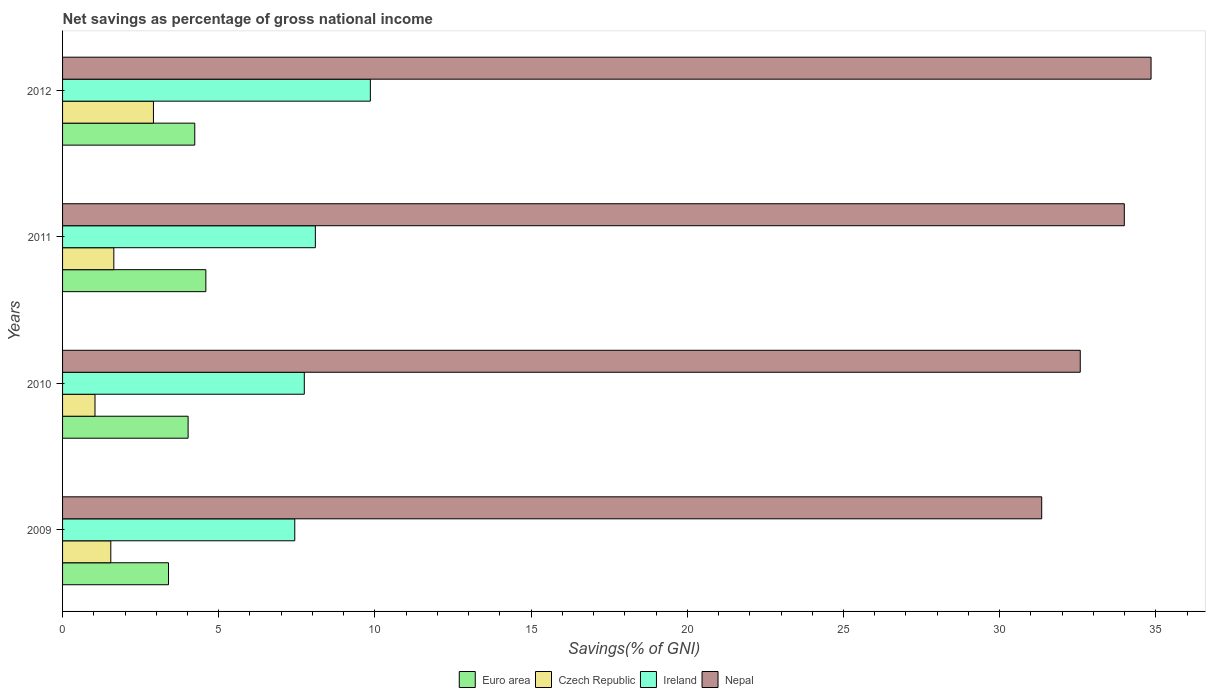How many groups of bars are there?
Your response must be concise. 4. Are the number of bars per tick equal to the number of legend labels?
Offer a terse response. Yes. Are the number of bars on each tick of the Y-axis equal?
Offer a very short reply. Yes. How many bars are there on the 1st tick from the bottom?
Make the answer very short. 4. What is the label of the 3rd group of bars from the top?
Ensure brevity in your answer.  2010. What is the total savings in Czech Republic in 2010?
Your answer should be very brief. 1.04. Across all years, what is the maximum total savings in Euro area?
Your answer should be very brief. 4.59. Across all years, what is the minimum total savings in Euro area?
Offer a very short reply. 3.39. In which year was the total savings in Ireland maximum?
Your answer should be compact. 2012. In which year was the total savings in Euro area minimum?
Your answer should be compact. 2009. What is the total total savings in Ireland in the graph?
Provide a succinct answer. 33.12. What is the difference between the total savings in Ireland in 2010 and that in 2011?
Provide a succinct answer. -0.35. What is the difference between the total savings in Nepal in 2010 and the total savings in Czech Republic in 2012?
Ensure brevity in your answer.  29.67. What is the average total savings in Czech Republic per year?
Offer a very short reply. 1.78. In the year 2010, what is the difference between the total savings in Euro area and total savings in Czech Republic?
Your answer should be compact. 2.98. In how many years, is the total savings in Nepal greater than 32 %?
Your answer should be very brief. 3. What is the ratio of the total savings in Ireland in 2010 to that in 2011?
Your answer should be compact. 0.96. Is the total savings in Czech Republic in 2010 less than that in 2012?
Provide a short and direct response. Yes. Is the difference between the total savings in Euro area in 2009 and 2011 greater than the difference between the total savings in Czech Republic in 2009 and 2011?
Keep it short and to the point. No. What is the difference between the highest and the second highest total savings in Ireland?
Your response must be concise. 1.76. What is the difference between the highest and the lowest total savings in Ireland?
Your answer should be compact. 2.42. Is the sum of the total savings in Nepal in 2010 and 2012 greater than the maximum total savings in Czech Republic across all years?
Keep it short and to the point. Yes. What does the 1st bar from the top in 2009 represents?
Offer a terse response. Nepal. What does the 4th bar from the bottom in 2012 represents?
Offer a terse response. Nepal. Is it the case that in every year, the sum of the total savings in Czech Republic and total savings in Ireland is greater than the total savings in Euro area?
Ensure brevity in your answer.  Yes. How many bars are there?
Your answer should be compact. 16. How many years are there in the graph?
Your answer should be very brief. 4. What is the difference between two consecutive major ticks on the X-axis?
Your response must be concise. 5. Are the values on the major ticks of X-axis written in scientific E-notation?
Your answer should be compact. No. Does the graph contain any zero values?
Your answer should be very brief. No. How many legend labels are there?
Keep it short and to the point. 4. How are the legend labels stacked?
Provide a short and direct response. Horizontal. What is the title of the graph?
Keep it short and to the point. Net savings as percentage of gross national income. Does "Malawi" appear as one of the legend labels in the graph?
Ensure brevity in your answer.  No. What is the label or title of the X-axis?
Your answer should be compact. Savings(% of GNI). What is the label or title of the Y-axis?
Your answer should be compact. Years. What is the Savings(% of GNI) of Euro area in 2009?
Provide a succinct answer. 3.39. What is the Savings(% of GNI) of Czech Republic in 2009?
Provide a succinct answer. 1.54. What is the Savings(% of GNI) of Ireland in 2009?
Keep it short and to the point. 7.43. What is the Savings(% of GNI) of Nepal in 2009?
Give a very brief answer. 31.35. What is the Savings(% of GNI) in Euro area in 2010?
Make the answer very short. 4.02. What is the Savings(% of GNI) of Czech Republic in 2010?
Your answer should be very brief. 1.04. What is the Savings(% of GNI) in Ireland in 2010?
Provide a short and direct response. 7.74. What is the Savings(% of GNI) in Nepal in 2010?
Provide a succinct answer. 32.58. What is the Savings(% of GNI) in Euro area in 2011?
Keep it short and to the point. 4.59. What is the Savings(% of GNI) of Czech Republic in 2011?
Give a very brief answer. 1.64. What is the Savings(% of GNI) of Ireland in 2011?
Your response must be concise. 8.09. What is the Savings(% of GNI) of Nepal in 2011?
Offer a terse response. 33.99. What is the Savings(% of GNI) of Euro area in 2012?
Provide a short and direct response. 4.23. What is the Savings(% of GNI) of Czech Republic in 2012?
Your answer should be compact. 2.91. What is the Savings(% of GNI) of Ireland in 2012?
Provide a succinct answer. 9.85. What is the Savings(% of GNI) of Nepal in 2012?
Your answer should be compact. 34.85. Across all years, what is the maximum Savings(% of GNI) of Euro area?
Offer a terse response. 4.59. Across all years, what is the maximum Savings(% of GNI) in Czech Republic?
Give a very brief answer. 2.91. Across all years, what is the maximum Savings(% of GNI) in Ireland?
Your answer should be very brief. 9.85. Across all years, what is the maximum Savings(% of GNI) of Nepal?
Your answer should be compact. 34.85. Across all years, what is the minimum Savings(% of GNI) in Euro area?
Give a very brief answer. 3.39. Across all years, what is the minimum Savings(% of GNI) of Czech Republic?
Your response must be concise. 1.04. Across all years, what is the minimum Savings(% of GNI) of Ireland?
Give a very brief answer. 7.43. Across all years, what is the minimum Savings(% of GNI) in Nepal?
Offer a very short reply. 31.35. What is the total Savings(% of GNI) in Euro area in the graph?
Your answer should be compact. 16.23. What is the total Savings(% of GNI) of Czech Republic in the graph?
Your response must be concise. 7.13. What is the total Savings(% of GNI) of Ireland in the graph?
Keep it short and to the point. 33.12. What is the total Savings(% of GNI) of Nepal in the graph?
Ensure brevity in your answer.  132.77. What is the difference between the Savings(% of GNI) in Euro area in 2009 and that in 2010?
Provide a short and direct response. -0.63. What is the difference between the Savings(% of GNI) of Czech Republic in 2009 and that in 2010?
Provide a succinct answer. 0.51. What is the difference between the Savings(% of GNI) of Ireland in 2009 and that in 2010?
Make the answer very short. -0.31. What is the difference between the Savings(% of GNI) of Nepal in 2009 and that in 2010?
Keep it short and to the point. -1.23. What is the difference between the Savings(% of GNI) of Euro area in 2009 and that in 2011?
Ensure brevity in your answer.  -1.2. What is the difference between the Savings(% of GNI) in Czech Republic in 2009 and that in 2011?
Provide a succinct answer. -0.1. What is the difference between the Savings(% of GNI) in Ireland in 2009 and that in 2011?
Your answer should be very brief. -0.66. What is the difference between the Savings(% of GNI) in Nepal in 2009 and that in 2011?
Offer a very short reply. -2.64. What is the difference between the Savings(% of GNI) of Euro area in 2009 and that in 2012?
Give a very brief answer. -0.84. What is the difference between the Savings(% of GNI) in Czech Republic in 2009 and that in 2012?
Provide a succinct answer. -1.37. What is the difference between the Savings(% of GNI) of Ireland in 2009 and that in 2012?
Provide a short and direct response. -2.42. What is the difference between the Savings(% of GNI) in Nepal in 2009 and that in 2012?
Give a very brief answer. -3.5. What is the difference between the Savings(% of GNI) of Euro area in 2010 and that in 2011?
Your answer should be compact. -0.57. What is the difference between the Savings(% of GNI) in Czech Republic in 2010 and that in 2011?
Give a very brief answer. -0.6. What is the difference between the Savings(% of GNI) in Ireland in 2010 and that in 2011?
Your answer should be compact. -0.35. What is the difference between the Savings(% of GNI) of Nepal in 2010 and that in 2011?
Offer a very short reply. -1.41. What is the difference between the Savings(% of GNI) in Euro area in 2010 and that in 2012?
Provide a short and direct response. -0.21. What is the difference between the Savings(% of GNI) of Czech Republic in 2010 and that in 2012?
Your response must be concise. -1.87. What is the difference between the Savings(% of GNI) of Ireland in 2010 and that in 2012?
Your response must be concise. -2.12. What is the difference between the Savings(% of GNI) in Nepal in 2010 and that in 2012?
Your answer should be compact. -2.27. What is the difference between the Savings(% of GNI) of Euro area in 2011 and that in 2012?
Offer a terse response. 0.35. What is the difference between the Savings(% of GNI) in Czech Republic in 2011 and that in 2012?
Offer a terse response. -1.27. What is the difference between the Savings(% of GNI) of Ireland in 2011 and that in 2012?
Make the answer very short. -1.76. What is the difference between the Savings(% of GNI) in Nepal in 2011 and that in 2012?
Provide a succinct answer. -0.86. What is the difference between the Savings(% of GNI) of Euro area in 2009 and the Savings(% of GNI) of Czech Republic in 2010?
Keep it short and to the point. 2.35. What is the difference between the Savings(% of GNI) of Euro area in 2009 and the Savings(% of GNI) of Ireland in 2010?
Ensure brevity in your answer.  -4.35. What is the difference between the Savings(% of GNI) of Euro area in 2009 and the Savings(% of GNI) of Nepal in 2010?
Provide a short and direct response. -29.19. What is the difference between the Savings(% of GNI) of Czech Republic in 2009 and the Savings(% of GNI) of Ireland in 2010?
Your answer should be very brief. -6.19. What is the difference between the Savings(% of GNI) of Czech Republic in 2009 and the Savings(% of GNI) of Nepal in 2010?
Provide a short and direct response. -31.04. What is the difference between the Savings(% of GNI) of Ireland in 2009 and the Savings(% of GNI) of Nepal in 2010?
Provide a short and direct response. -25.15. What is the difference between the Savings(% of GNI) of Euro area in 2009 and the Savings(% of GNI) of Czech Republic in 2011?
Make the answer very short. 1.75. What is the difference between the Savings(% of GNI) in Euro area in 2009 and the Savings(% of GNI) in Ireland in 2011?
Offer a very short reply. -4.7. What is the difference between the Savings(% of GNI) of Euro area in 2009 and the Savings(% of GNI) of Nepal in 2011?
Give a very brief answer. -30.6. What is the difference between the Savings(% of GNI) of Czech Republic in 2009 and the Savings(% of GNI) of Ireland in 2011?
Give a very brief answer. -6.55. What is the difference between the Savings(% of GNI) in Czech Republic in 2009 and the Savings(% of GNI) in Nepal in 2011?
Provide a short and direct response. -32.45. What is the difference between the Savings(% of GNI) in Ireland in 2009 and the Savings(% of GNI) in Nepal in 2011?
Make the answer very short. -26.56. What is the difference between the Savings(% of GNI) of Euro area in 2009 and the Savings(% of GNI) of Czech Republic in 2012?
Offer a very short reply. 0.48. What is the difference between the Savings(% of GNI) in Euro area in 2009 and the Savings(% of GNI) in Ireland in 2012?
Offer a terse response. -6.46. What is the difference between the Savings(% of GNI) in Euro area in 2009 and the Savings(% of GNI) in Nepal in 2012?
Give a very brief answer. -31.46. What is the difference between the Savings(% of GNI) of Czech Republic in 2009 and the Savings(% of GNI) of Ireland in 2012?
Keep it short and to the point. -8.31. What is the difference between the Savings(% of GNI) in Czech Republic in 2009 and the Savings(% of GNI) in Nepal in 2012?
Keep it short and to the point. -33.3. What is the difference between the Savings(% of GNI) of Ireland in 2009 and the Savings(% of GNI) of Nepal in 2012?
Provide a short and direct response. -27.41. What is the difference between the Savings(% of GNI) of Euro area in 2010 and the Savings(% of GNI) of Czech Republic in 2011?
Your response must be concise. 2.38. What is the difference between the Savings(% of GNI) in Euro area in 2010 and the Savings(% of GNI) in Ireland in 2011?
Offer a very short reply. -4.07. What is the difference between the Savings(% of GNI) of Euro area in 2010 and the Savings(% of GNI) of Nepal in 2011?
Provide a short and direct response. -29.97. What is the difference between the Savings(% of GNI) of Czech Republic in 2010 and the Savings(% of GNI) of Ireland in 2011?
Offer a very short reply. -7.05. What is the difference between the Savings(% of GNI) in Czech Republic in 2010 and the Savings(% of GNI) in Nepal in 2011?
Give a very brief answer. -32.95. What is the difference between the Savings(% of GNI) of Ireland in 2010 and the Savings(% of GNI) of Nepal in 2011?
Your answer should be very brief. -26.25. What is the difference between the Savings(% of GNI) of Euro area in 2010 and the Savings(% of GNI) of Czech Republic in 2012?
Your answer should be compact. 1.11. What is the difference between the Savings(% of GNI) in Euro area in 2010 and the Savings(% of GNI) in Ireland in 2012?
Make the answer very short. -5.83. What is the difference between the Savings(% of GNI) of Euro area in 2010 and the Savings(% of GNI) of Nepal in 2012?
Your answer should be very brief. -30.83. What is the difference between the Savings(% of GNI) of Czech Republic in 2010 and the Savings(% of GNI) of Ireland in 2012?
Provide a succinct answer. -8.82. What is the difference between the Savings(% of GNI) in Czech Republic in 2010 and the Savings(% of GNI) in Nepal in 2012?
Your answer should be very brief. -33.81. What is the difference between the Savings(% of GNI) of Ireland in 2010 and the Savings(% of GNI) of Nepal in 2012?
Keep it short and to the point. -27.11. What is the difference between the Savings(% of GNI) of Euro area in 2011 and the Savings(% of GNI) of Czech Republic in 2012?
Provide a short and direct response. 1.68. What is the difference between the Savings(% of GNI) of Euro area in 2011 and the Savings(% of GNI) of Ireland in 2012?
Your answer should be compact. -5.27. What is the difference between the Savings(% of GNI) of Euro area in 2011 and the Savings(% of GNI) of Nepal in 2012?
Provide a short and direct response. -30.26. What is the difference between the Savings(% of GNI) in Czech Republic in 2011 and the Savings(% of GNI) in Ireland in 2012?
Provide a short and direct response. -8.21. What is the difference between the Savings(% of GNI) of Czech Republic in 2011 and the Savings(% of GNI) of Nepal in 2012?
Your response must be concise. -33.21. What is the difference between the Savings(% of GNI) of Ireland in 2011 and the Savings(% of GNI) of Nepal in 2012?
Your answer should be compact. -26.75. What is the average Savings(% of GNI) in Euro area per year?
Ensure brevity in your answer.  4.06. What is the average Savings(% of GNI) of Czech Republic per year?
Offer a very short reply. 1.78. What is the average Savings(% of GNI) in Ireland per year?
Offer a terse response. 8.28. What is the average Savings(% of GNI) in Nepal per year?
Keep it short and to the point. 33.19. In the year 2009, what is the difference between the Savings(% of GNI) of Euro area and Savings(% of GNI) of Czech Republic?
Provide a succinct answer. 1.85. In the year 2009, what is the difference between the Savings(% of GNI) in Euro area and Savings(% of GNI) in Ireland?
Your answer should be very brief. -4.04. In the year 2009, what is the difference between the Savings(% of GNI) of Euro area and Savings(% of GNI) of Nepal?
Make the answer very short. -27.95. In the year 2009, what is the difference between the Savings(% of GNI) of Czech Republic and Savings(% of GNI) of Ireland?
Make the answer very short. -5.89. In the year 2009, what is the difference between the Savings(% of GNI) in Czech Republic and Savings(% of GNI) in Nepal?
Your answer should be compact. -29.8. In the year 2009, what is the difference between the Savings(% of GNI) of Ireland and Savings(% of GNI) of Nepal?
Your answer should be compact. -23.91. In the year 2010, what is the difference between the Savings(% of GNI) of Euro area and Savings(% of GNI) of Czech Republic?
Your answer should be compact. 2.98. In the year 2010, what is the difference between the Savings(% of GNI) in Euro area and Savings(% of GNI) in Ireland?
Provide a short and direct response. -3.72. In the year 2010, what is the difference between the Savings(% of GNI) of Euro area and Savings(% of GNI) of Nepal?
Make the answer very short. -28.56. In the year 2010, what is the difference between the Savings(% of GNI) in Czech Republic and Savings(% of GNI) in Ireland?
Your response must be concise. -6.7. In the year 2010, what is the difference between the Savings(% of GNI) of Czech Republic and Savings(% of GNI) of Nepal?
Give a very brief answer. -31.54. In the year 2010, what is the difference between the Savings(% of GNI) of Ireland and Savings(% of GNI) of Nepal?
Your response must be concise. -24.84. In the year 2011, what is the difference between the Savings(% of GNI) in Euro area and Savings(% of GNI) in Czech Republic?
Provide a succinct answer. 2.95. In the year 2011, what is the difference between the Savings(% of GNI) of Euro area and Savings(% of GNI) of Ireland?
Offer a very short reply. -3.51. In the year 2011, what is the difference between the Savings(% of GNI) in Euro area and Savings(% of GNI) in Nepal?
Give a very brief answer. -29.4. In the year 2011, what is the difference between the Savings(% of GNI) of Czech Republic and Savings(% of GNI) of Ireland?
Your answer should be compact. -6.45. In the year 2011, what is the difference between the Savings(% of GNI) of Czech Republic and Savings(% of GNI) of Nepal?
Offer a very short reply. -32.35. In the year 2011, what is the difference between the Savings(% of GNI) of Ireland and Savings(% of GNI) of Nepal?
Provide a short and direct response. -25.9. In the year 2012, what is the difference between the Savings(% of GNI) in Euro area and Savings(% of GNI) in Czech Republic?
Your answer should be very brief. 1.32. In the year 2012, what is the difference between the Savings(% of GNI) of Euro area and Savings(% of GNI) of Ireland?
Give a very brief answer. -5.62. In the year 2012, what is the difference between the Savings(% of GNI) in Euro area and Savings(% of GNI) in Nepal?
Keep it short and to the point. -30.62. In the year 2012, what is the difference between the Savings(% of GNI) in Czech Republic and Savings(% of GNI) in Ireland?
Your response must be concise. -6.94. In the year 2012, what is the difference between the Savings(% of GNI) of Czech Republic and Savings(% of GNI) of Nepal?
Offer a very short reply. -31.94. In the year 2012, what is the difference between the Savings(% of GNI) in Ireland and Savings(% of GNI) in Nepal?
Offer a terse response. -24.99. What is the ratio of the Savings(% of GNI) of Euro area in 2009 to that in 2010?
Your answer should be compact. 0.84. What is the ratio of the Savings(% of GNI) in Czech Republic in 2009 to that in 2010?
Make the answer very short. 1.49. What is the ratio of the Savings(% of GNI) of Ireland in 2009 to that in 2010?
Keep it short and to the point. 0.96. What is the ratio of the Savings(% of GNI) of Nepal in 2009 to that in 2010?
Offer a very short reply. 0.96. What is the ratio of the Savings(% of GNI) of Euro area in 2009 to that in 2011?
Offer a very short reply. 0.74. What is the ratio of the Savings(% of GNI) in Czech Republic in 2009 to that in 2011?
Ensure brevity in your answer.  0.94. What is the ratio of the Savings(% of GNI) of Ireland in 2009 to that in 2011?
Make the answer very short. 0.92. What is the ratio of the Savings(% of GNI) of Nepal in 2009 to that in 2011?
Provide a succinct answer. 0.92. What is the ratio of the Savings(% of GNI) of Euro area in 2009 to that in 2012?
Offer a terse response. 0.8. What is the ratio of the Savings(% of GNI) in Czech Republic in 2009 to that in 2012?
Your answer should be very brief. 0.53. What is the ratio of the Savings(% of GNI) of Ireland in 2009 to that in 2012?
Make the answer very short. 0.75. What is the ratio of the Savings(% of GNI) in Nepal in 2009 to that in 2012?
Give a very brief answer. 0.9. What is the ratio of the Savings(% of GNI) of Euro area in 2010 to that in 2011?
Your answer should be compact. 0.88. What is the ratio of the Savings(% of GNI) in Czech Republic in 2010 to that in 2011?
Offer a very short reply. 0.63. What is the ratio of the Savings(% of GNI) in Ireland in 2010 to that in 2011?
Offer a very short reply. 0.96. What is the ratio of the Savings(% of GNI) of Nepal in 2010 to that in 2011?
Provide a succinct answer. 0.96. What is the ratio of the Savings(% of GNI) in Euro area in 2010 to that in 2012?
Make the answer very short. 0.95. What is the ratio of the Savings(% of GNI) in Czech Republic in 2010 to that in 2012?
Your response must be concise. 0.36. What is the ratio of the Savings(% of GNI) in Ireland in 2010 to that in 2012?
Your answer should be very brief. 0.79. What is the ratio of the Savings(% of GNI) of Nepal in 2010 to that in 2012?
Offer a very short reply. 0.93. What is the ratio of the Savings(% of GNI) in Euro area in 2011 to that in 2012?
Provide a short and direct response. 1.08. What is the ratio of the Savings(% of GNI) in Czech Republic in 2011 to that in 2012?
Offer a very short reply. 0.56. What is the ratio of the Savings(% of GNI) in Ireland in 2011 to that in 2012?
Keep it short and to the point. 0.82. What is the ratio of the Savings(% of GNI) in Nepal in 2011 to that in 2012?
Offer a terse response. 0.98. What is the difference between the highest and the second highest Savings(% of GNI) in Euro area?
Ensure brevity in your answer.  0.35. What is the difference between the highest and the second highest Savings(% of GNI) in Czech Republic?
Your answer should be compact. 1.27. What is the difference between the highest and the second highest Savings(% of GNI) in Ireland?
Ensure brevity in your answer.  1.76. What is the difference between the highest and the second highest Savings(% of GNI) in Nepal?
Offer a very short reply. 0.86. What is the difference between the highest and the lowest Savings(% of GNI) in Euro area?
Make the answer very short. 1.2. What is the difference between the highest and the lowest Savings(% of GNI) in Czech Republic?
Make the answer very short. 1.87. What is the difference between the highest and the lowest Savings(% of GNI) of Ireland?
Make the answer very short. 2.42. What is the difference between the highest and the lowest Savings(% of GNI) in Nepal?
Provide a short and direct response. 3.5. 